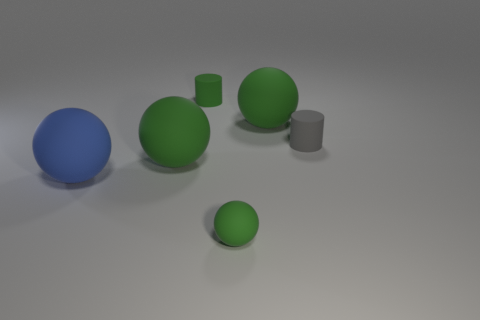Subtract all red cubes. How many green balls are left? 3 Subtract 1 spheres. How many spheres are left? 3 Subtract all red balls. Subtract all red blocks. How many balls are left? 4 Add 3 tiny yellow cubes. How many objects exist? 9 Subtract all cylinders. How many objects are left? 4 Subtract 0 cyan blocks. How many objects are left? 6 Subtract all big blue objects. Subtract all green matte cylinders. How many objects are left? 4 Add 3 small cylinders. How many small cylinders are left? 5 Add 5 large green spheres. How many large green spheres exist? 7 